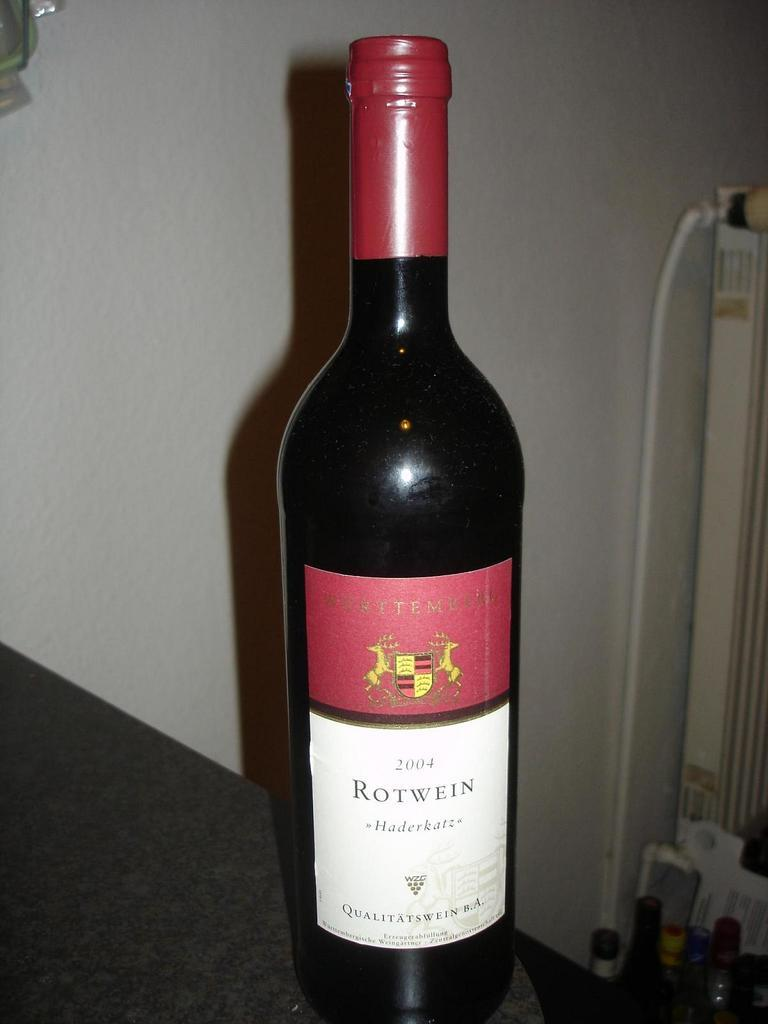<image>
Write a terse but informative summary of the picture. A Red bottle of wine with the Label ROTWEIN that is unopened and sitting next to a wine glass. 